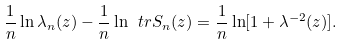Convert formula to latex. <formula><loc_0><loc_0><loc_500><loc_500>\frac { 1 } { n } \ln \lambda _ { n } ( z ) - \frac { 1 } { n } \ln \ t r S _ { n } ( z ) = \frac { 1 } { n } \ln [ 1 + \lambda ^ { - 2 } ( z ) ] .</formula> 